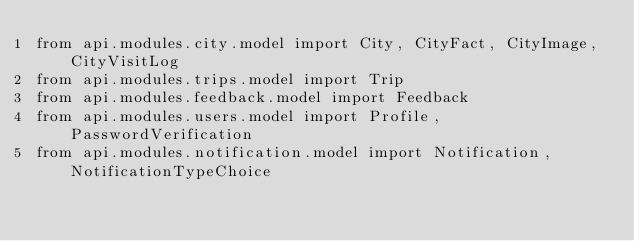<code> <loc_0><loc_0><loc_500><loc_500><_Python_>from api.modules.city.model import City, CityFact, CityImage, CityVisitLog
from api.modules.trips.model import Trip
from api.modules.feedback.model import Feedback
from api.modules.users.model import Profile, PasswordVerification
from api.modules.notification.model import Notification, NotificationTypeChoice
</code> 